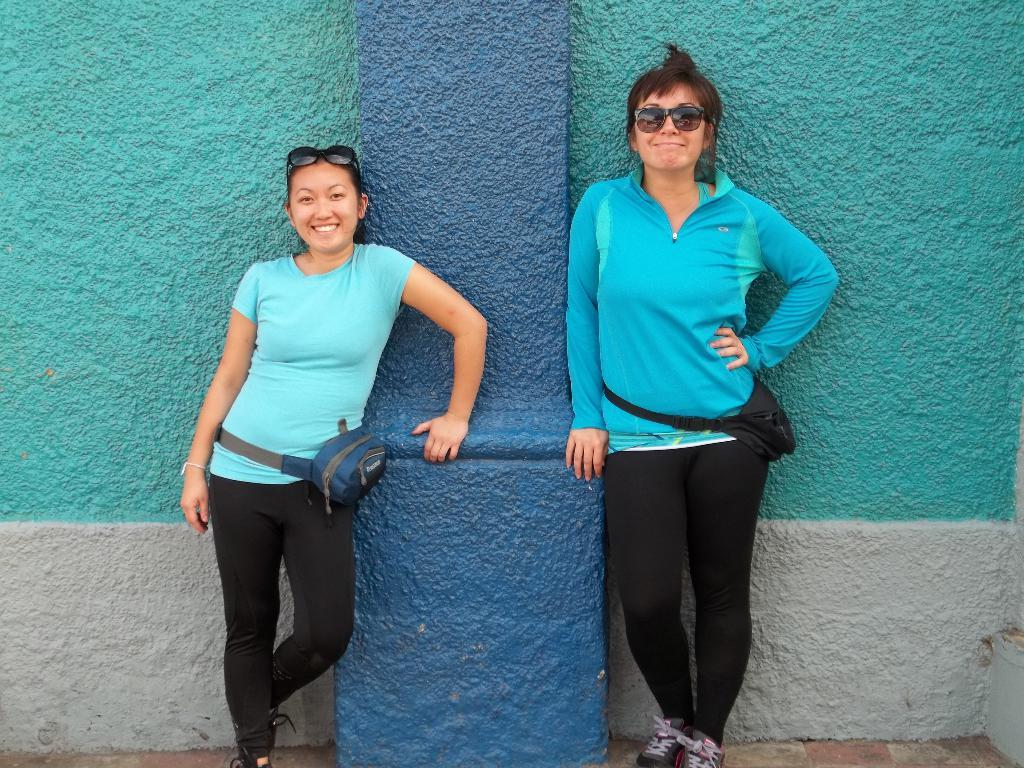How many people are in the image? There are two persons standing in the image. What is the surface they are standing on? The persons are standing on the ground. What can be seen in the background of the image? There is a wall and a pillar in the background of the image. What type of honey is being collected by the persons in the image? There is no honey or honey collection activity present in the image. In which direction are the persons facing in the image? The provided facts do not specify the direction the persons are facing, so it cannot be determined from the image. 